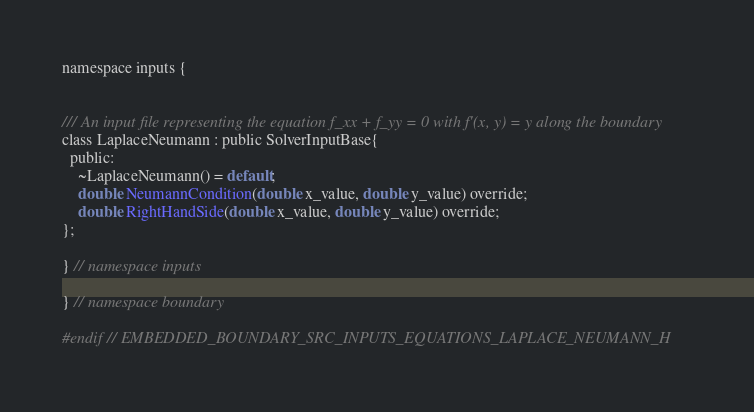Convert code to text. <code><loc_0><loc_0><loc_500><loc_500><_C_>
namespace inputs {


/// An input file representing the equation f_xx + f_yy = 0 with f'(x, y) = y along the boundary
class LaplaceNeumann : public SolverInputBase{
  public:
    ~LaplaceNeumann() = default;
    double NeumannCondition(double x_value, double y_value) override;
    double RightHandSide(double x_value, double y_value) override;
};

} // namespace inputs

} // namespace boundary

#endif // EMBEDDED_BOUNDARY_SRC_INPUTS_EQUATIONS_LAPLACE_NEUMANN_H
</code> 